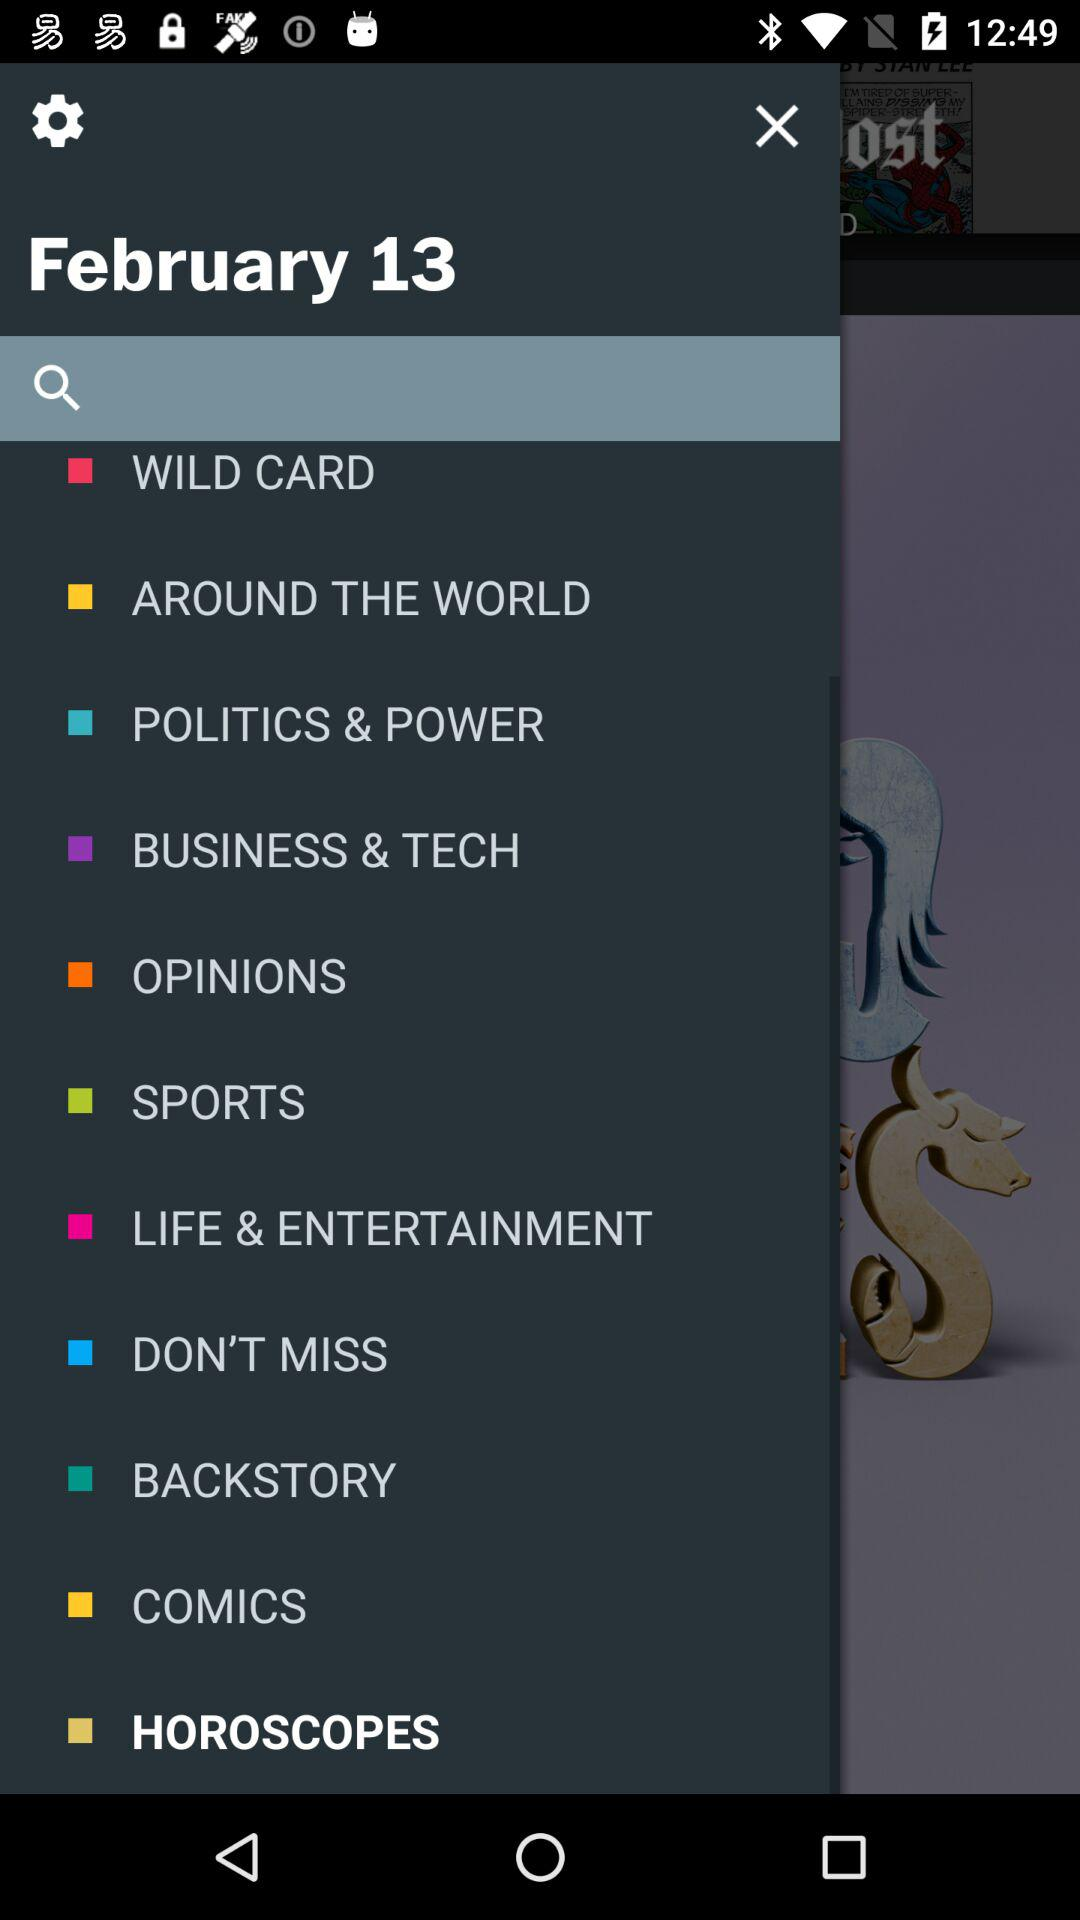What is the date shown on the screen? The date shown on the screen is February 13. 